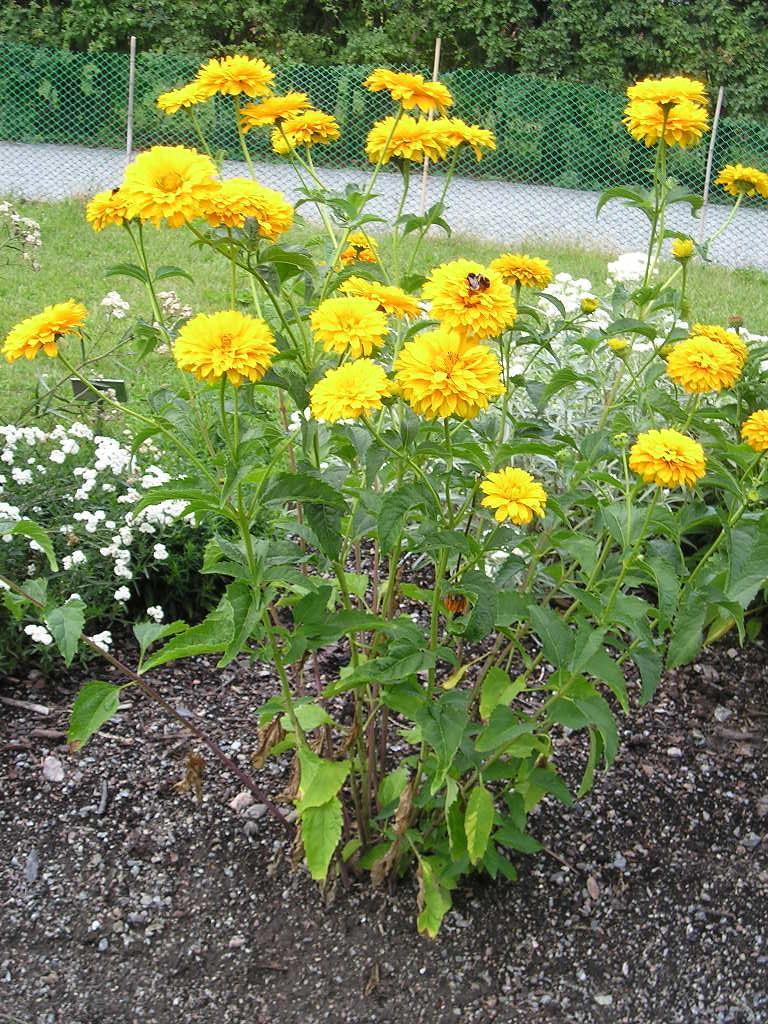How would you summarize this image in a sentence or two? In the middle of the image I can see trees with flowers. In the background, I can see grills and a group of trees. At the bottom of the image I can see sand. 